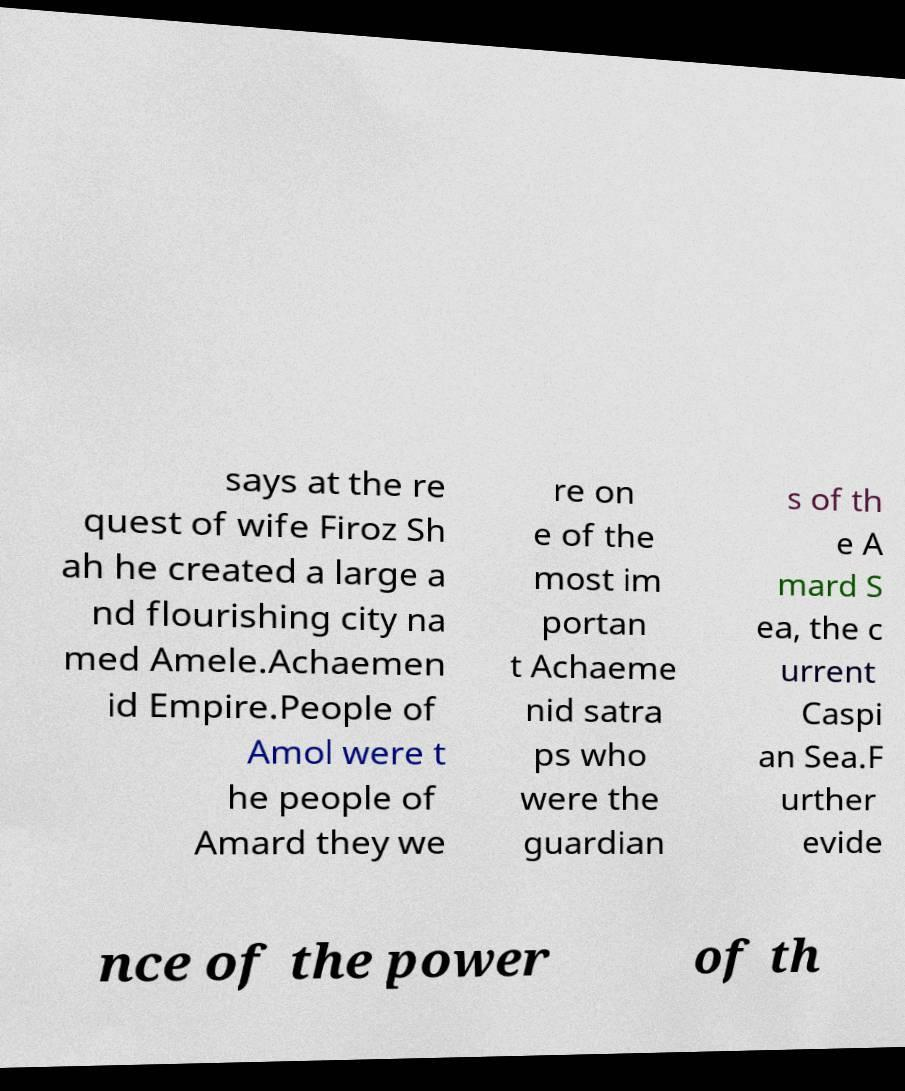Can you accurately transcribe the text from the provided image for me? says at the re quest of wife Firoz Sh ah he created a large a nd flourishing city na med Amele.Achaemen id Empire.People of Amol were t he people of Amard they we re on e of the most im portan t Achaeme nid satra ps who were the guardian s of th e A mard S ea, the c urrent Caspi an Sea.F urther evide nce of the power of th 